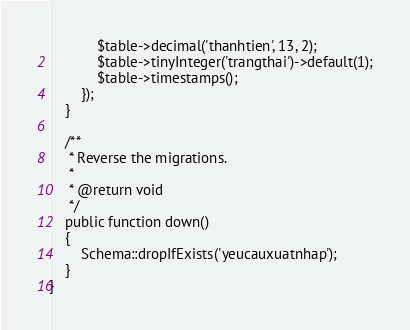Convert code to text. <code><loc_0><loc_0><loc_500><loc_500><_PHP_>            $table->decimal('thanhtien', 13, 2);
            $table->tinyInteger('trangthai')->default(1);
            $table->timestamps();
        });
    }

    /**
     * Reverse the migrations.
     *
     * @return void
     */
    public function down()
    {
        Schema::dropIfExists('yeucauxuatnhap');
    }
}
</code> 